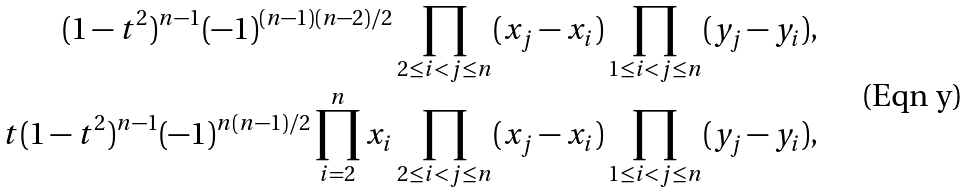<formula> <loc_0><loc_0><loc_500><loc_500>( 1 - t ^ { 2 } ) ^ { n - 1 } ( - 1 ) ^ { ( n - 1 ) ( n - 2 ) / 2 } \prod _ { 2 \leq i < j \leq n } ( x _ { j } - x _ { i } ) \prod _ { 1 \leq i < j \leq n } ( y _ { j } - y _ { i } ) , \\ t ( 1 - t ^ { 2 } ) ^ { n - 1 } ( - 1 ) ^ { n ( n - 1 ) / 2 } \prod _ { i = 2 } ^ { n } x _ { i } \prod _ { 2 \leq i < j \leq n } ( x _ { j } - x _ { i } ) \prod _ { 1 \leq i < j \leq n } ( y _ { j } - y _ { i } ) ,</formula> 